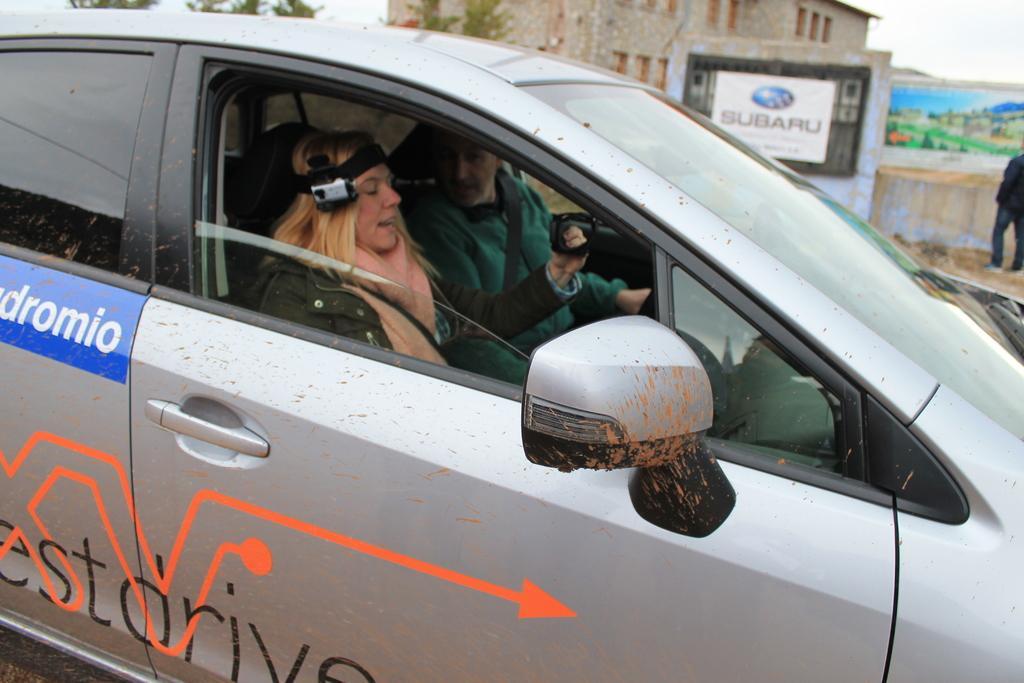Could you give a brief overview of what you see in this image? In the center we can see two persons were sitting in the vehicle. Coming to the background we can see the building and one person standing. 